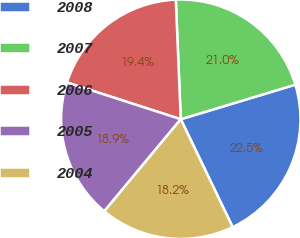Convert chart. <chart><loc_0><loc_0><loc_500><loc_500><pie_chart><fcel>2008<fcel>2007<fcel>2006<fcel>2005<fcel>2004<nl><fcel>22.53%<fcel>21.0%<fcel>19.37%<fcel>18.93%<fcel>18.17%<nl></chart> 